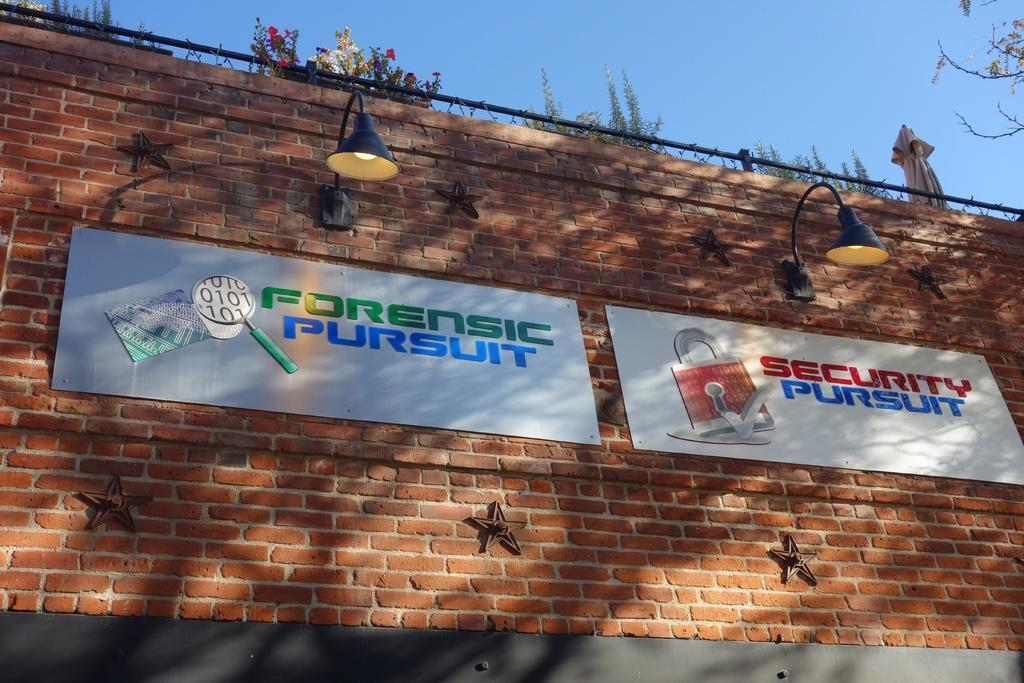What type of structure is visible in the image? There is a brick wall in the image. What is attached to the brick wall? There are two hoardings and two lamps on the wall. What type of vegetation is present in the image? There are plants and flowers in the image. What is visible at the top of the image? The sky is visible at the top of the image. Can you provide a list of the jewels that are displayed on the hoardings in the image? There are no jewels displayed on the hoardings in the image; they are advertisements or announcements. What type of copy is written on the hoardings in the image? There is no specific copy mentioned in the facts provided, but the hoardings likely contain text or images related to advertisements or announcements. 